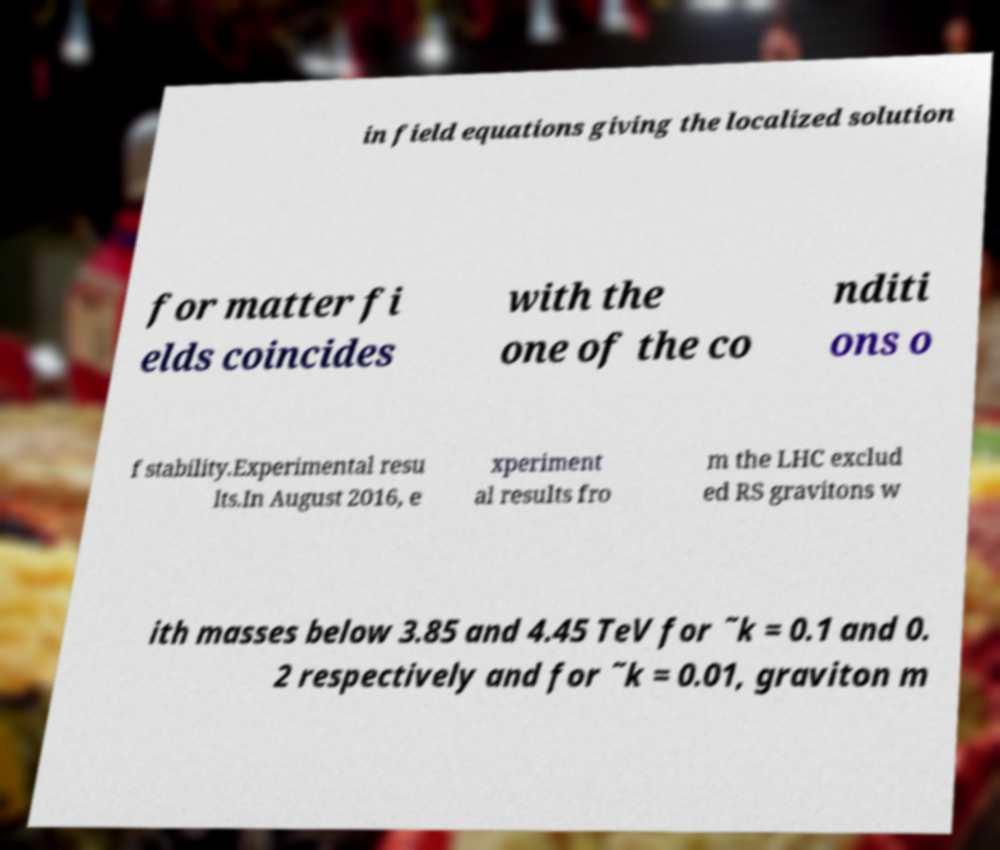Please read and relay the text visible in this image. What does it say? in field equations giving the localized solution for matter fi elds coincides with the one of the co nditi ons o f stability.Experimental resu lts.In August 2016, e xperiment al results fro m the LHC exclud ed RS gravitons w ith masses below 3.85 and 4.45 TeV for ˜k = 0.1 and 0. 2 respectively and for ˜k = 0.01, graviton m 